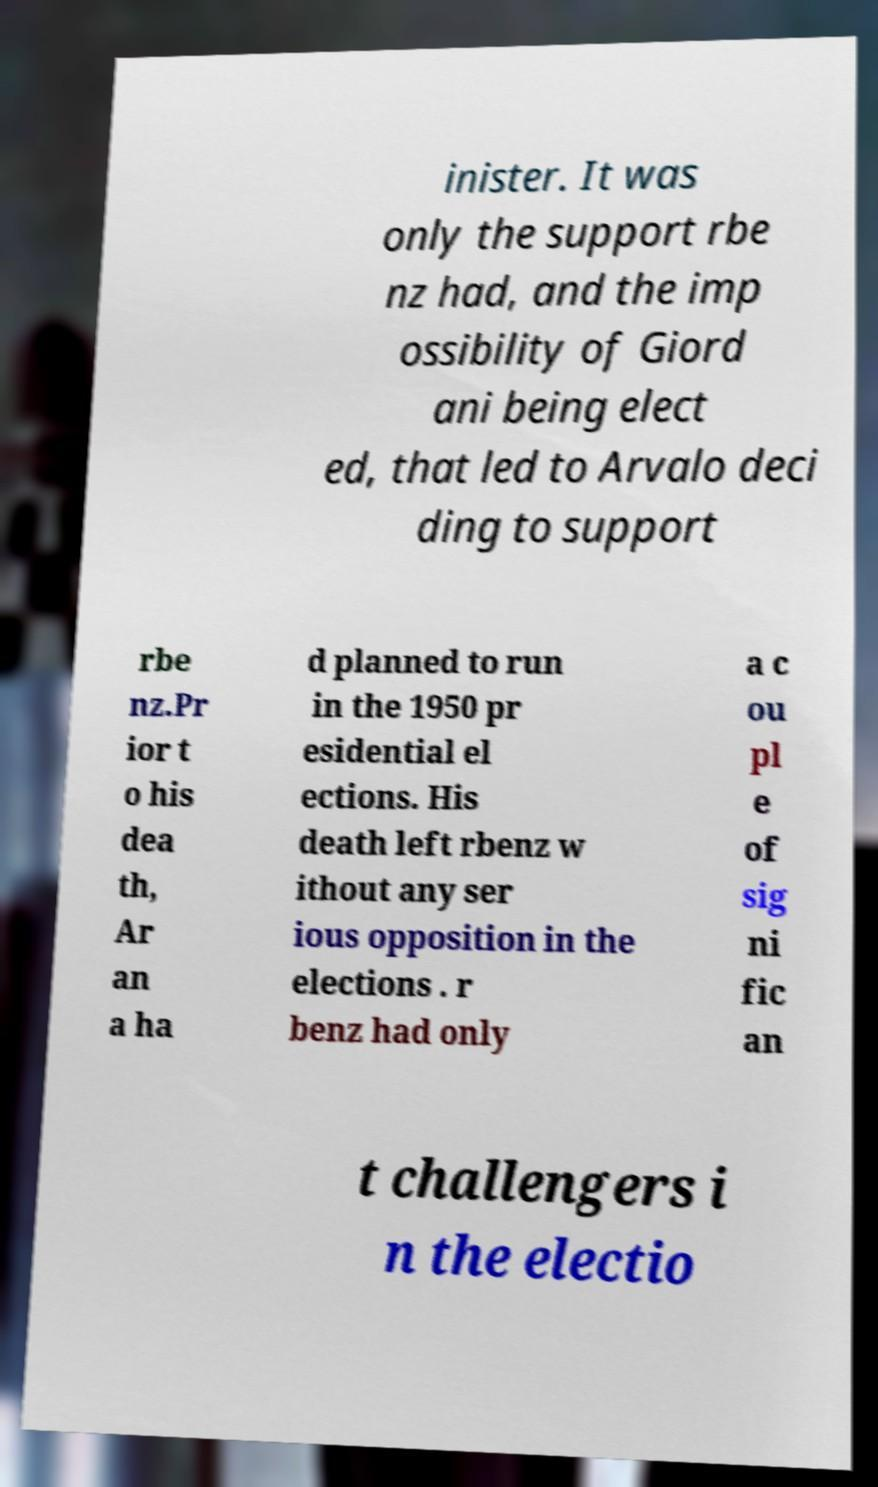Please identify and transcribe the text found in this image. inister. It was only the support rbe nz had, and the imp ossibility of Giord ani being elect ed, that led to Arvalo deci ding to support rbe nz.Pr ior t o his dea th, Ar an a ha d planned to run in the 1950 pr esidential el ections. His death left rbenz w ithout any ser ious opposition in the elections . r benz had only a c ou pl e of sig ni fic an t challengers i n the electio 